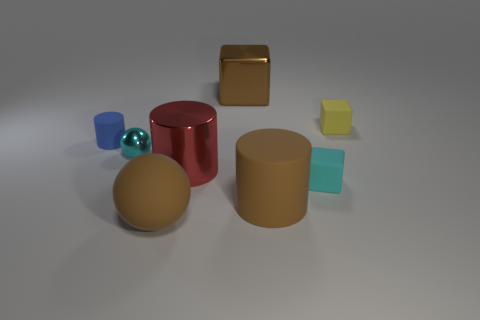There is a large brown thing behind the rubber thing that is behind the small blue matte cylinder; is there a large matte thing behind it?
Provide a succinct answer. No. There is a brown rubber object right of the big brown rubber ball; is its shape the same as the tiny matte thing left of the brown matte cylinder?
Your response must be concise. Yes. Is the number of balls left of the brown metal cube greater than the number of large spheres?
Give a very brief answer. Yes. What number of objects are either small cyan objects or tiny cyan shiny balls?
Provide a succinct answer. 2. The tiny metal thing has what color?
Give a very brief answer. Cyan. How many other things are there of the same color as the metallic cube?
Provide a succinct answer. 2. Are there any metal objects right of the red cylinder?
Offer a terse response. Yes. There is a large metallic thing left of the brown cube that is on the right side of the matte thing to the left of the large brown sphere; what is its color?
Give a very brief answer. Red. How many cylinders are left of the brown shiny thing and in front of the small cyan metal object?
Offer a very short reply. 1. How many cylinders are large brown objects or red metal things?
Offer a very short reply. 2. 